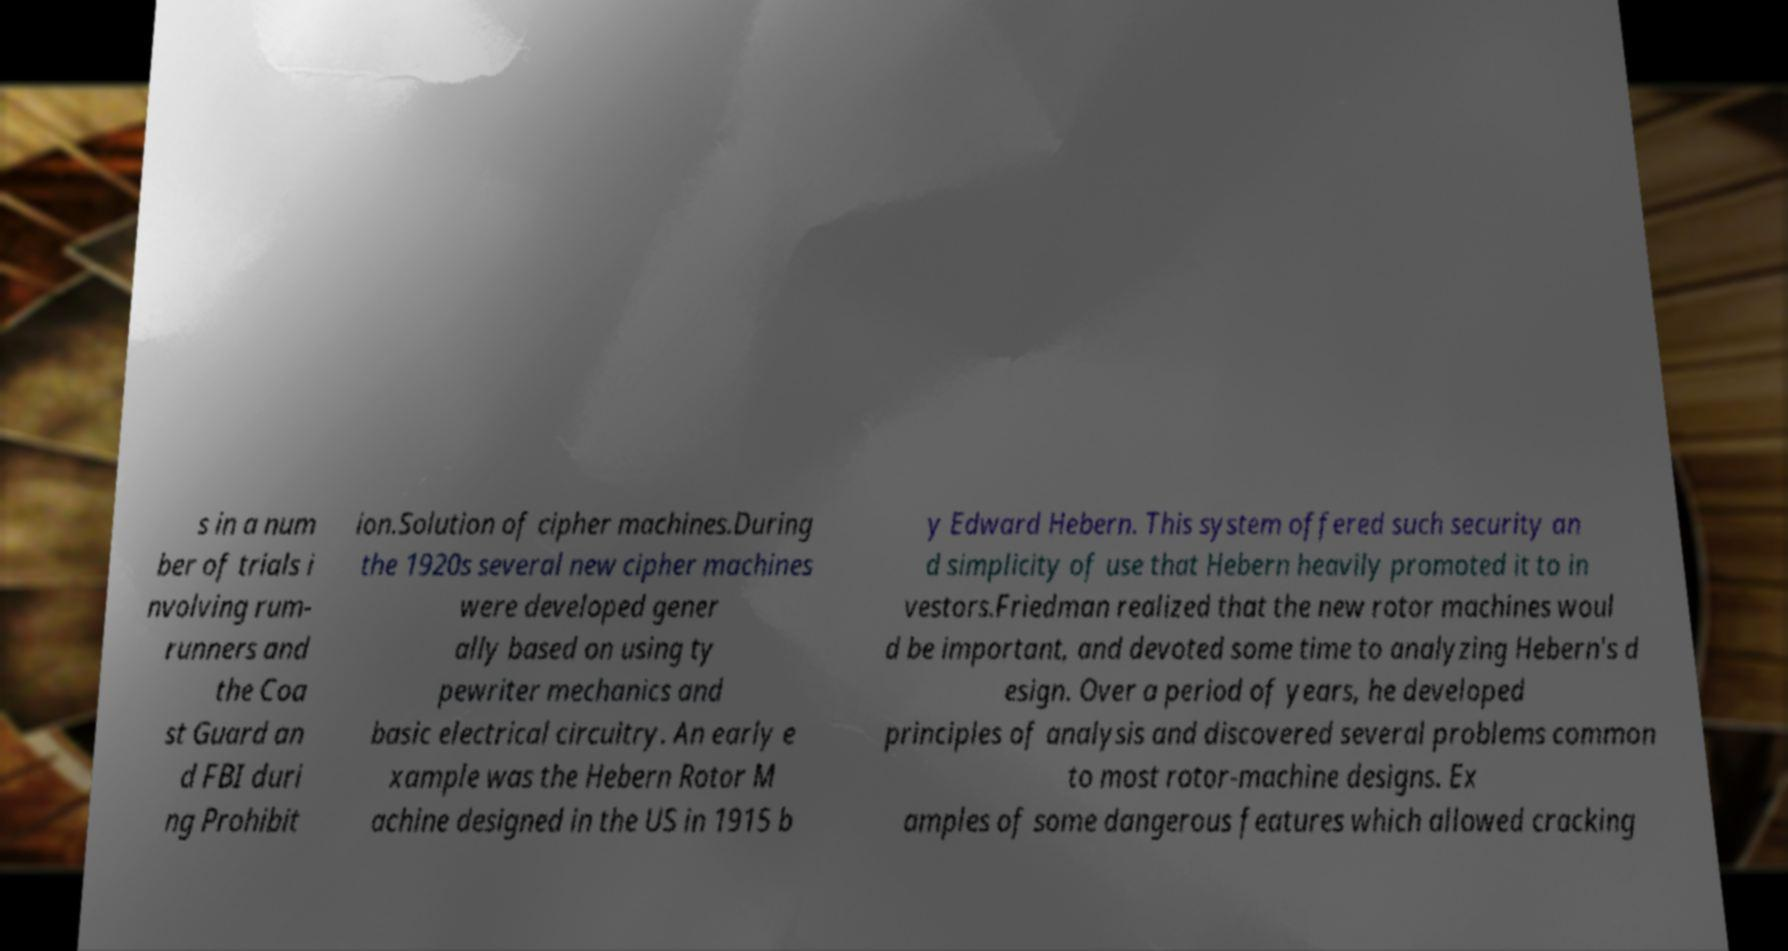Could you extract and type out the text from this image? s in a num ber of trials i nvolving rum- runners and the Coa st Guard an d FBI duri ng Prohibit ion.Solution of cipher machines.During the 1920s several new cipher machines were developed gener ally based on using ty pewriter mechanics and basic electrical circuitry. An early e xample was the Hebern Rotor M achine designed in the US in 1915 b y Edward Hebern. This system offered such security an d simplicity of use that Hebern heavily promoted it to in vestors.Friedman realized that the new rotor machines woul d be important, and devoted some time to analyzing Hebern's d esign. Over a period of years, he developed principles of analysis and discovered several problems common to most rotor-machine designs. Ex amples of some dangerous features which allowed cracking 